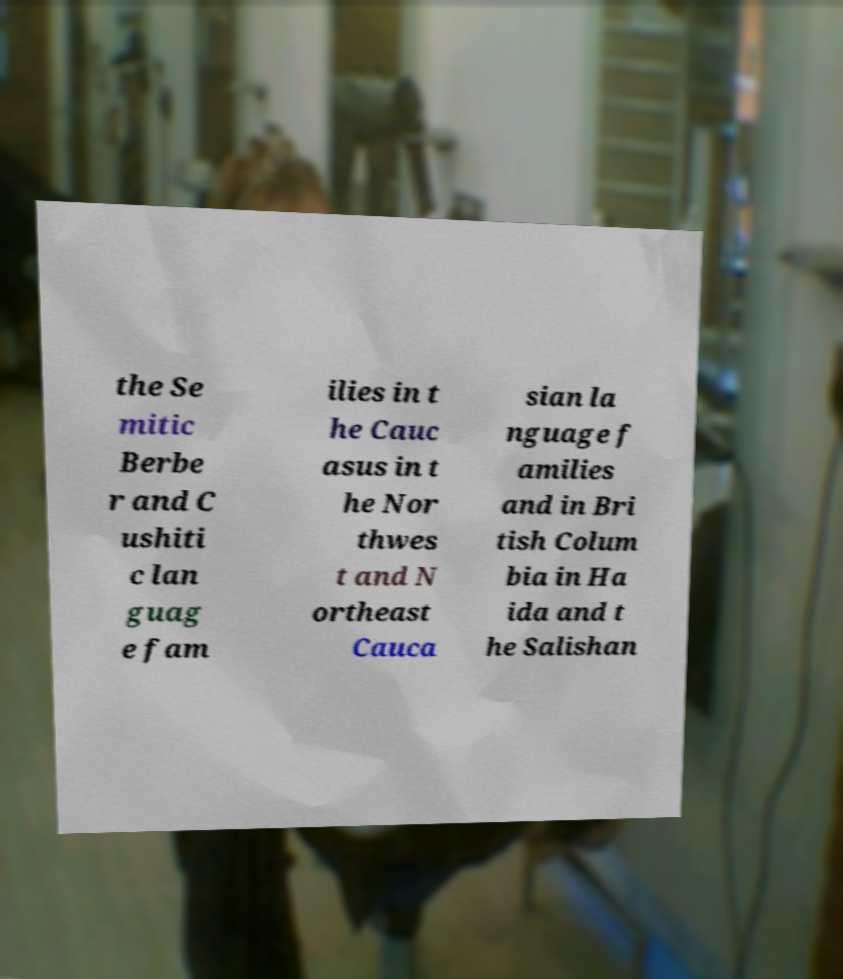Could you assist in decoding the text presented in this image and type it out clearly? the Se mitic Berbe r and C ushiti c lan guag e fam ilies in t he Cauc asus in t he Nor thwes t and N ortheast Cauca sian la nguage f amilies and in Bri tish Colum bia in Ha ida and t he Salishan 